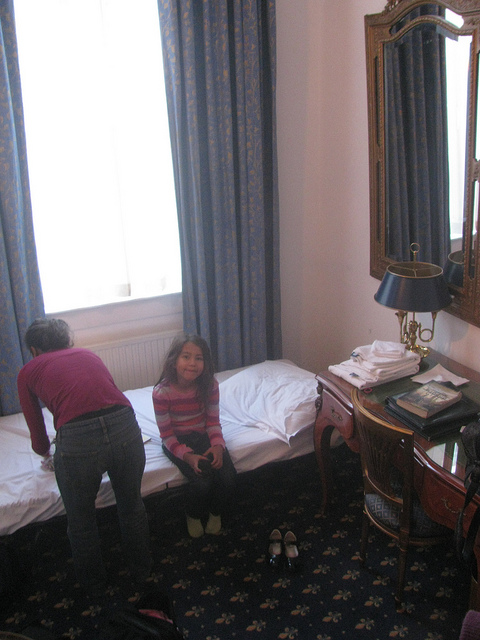What activity seems to be happening in the room? It appears that the room is being tidied up or arranged, as one person is standing by the bed and might be fixing the bedding or organizing items on it. Is there anything on the bed that provides a clue to this activity? Yes, there are what appear to be fresh linens or towels neatly placed on one of the beds, supporting the idea of tidying or room preparation. 